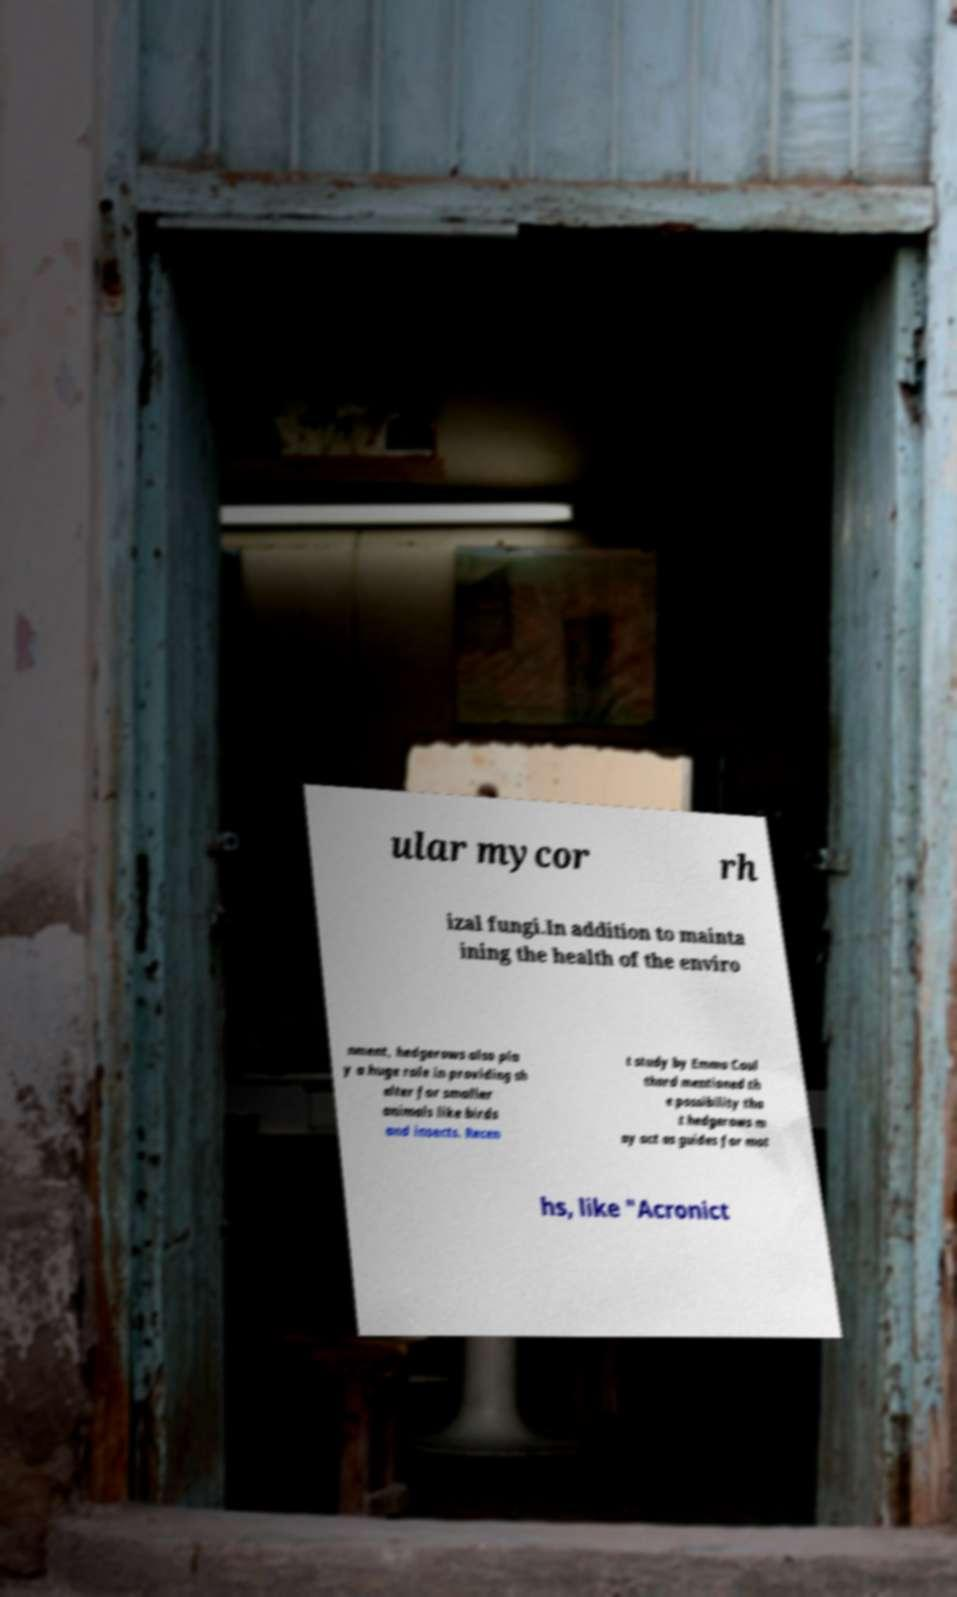Please read and relay the text visible in this image. What does it say? ular mycor rh izal fungi.In addition to mainta ining the health of the enviro nment, hedgerows also pla y a huge role in providing sh elter for smaller animals like birds and insects. Recen t study by Emma Coul thard mentioned th e possibility tha t hedgerows m ay act as guides for mot hs, like "Acronict 